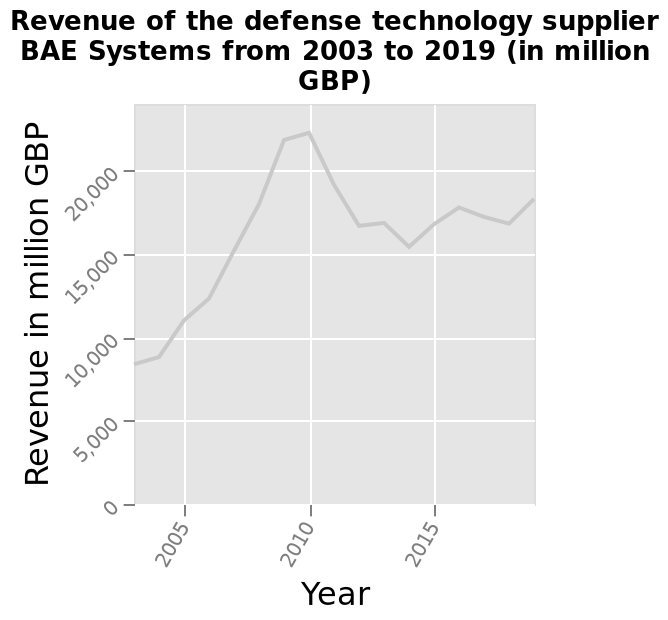<image>
In which year did BAE Systems have the highest revenue? BAE Systems had the highest revenue in the year 2019. What is the minimum revenue in million GBP for BAE Systems in the given time period? The minimum revenue for BAE Systems in the given time period is 0 million GBP. Describe the following image in detail Revenue of the defense technology supplier BAE Systems from 2003 to 2019 (in million GBP) is a line chart. There is a linear scale with a minimum of 0 and a maximum of 20,000 along the y-axis, labeled Revenue in million GBP. On the x-axis, Year is plotted. Is the sentence "Revenue of the defense technology supplier BAE Systems from 2003 to 2019 (in million GBP) is a bar graph. There is a logarithmic scale with a minimum of 0 and a maximum of 10,000 along the y-axis, labeled Revenue in thousand GBP. On the x-axis, Month is plotted." an interrogative sentence? No.Revenue of the defense technology supplier BAE Systems from 2003 to 2019 (in million GBP) is a line chart. There is a linear scale with a minimum of 0 and a maximum of 20,000 along the y-axis, labeled Revenue in million GBP. On the x-axis, Year is plotted. 